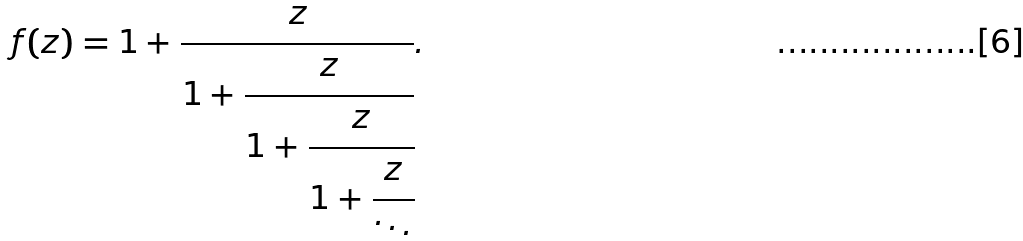Convert formula to latex. <formula><loc_0><loc_0><loc_500><loc_500>f ( z ) = 1 + { \cfrac { z } { 1 + { \cfrac { z } { 1 + { \cfrac { z } { 1 + { \cfrac { z } { \ddots } } } } } } } } .</formula> 